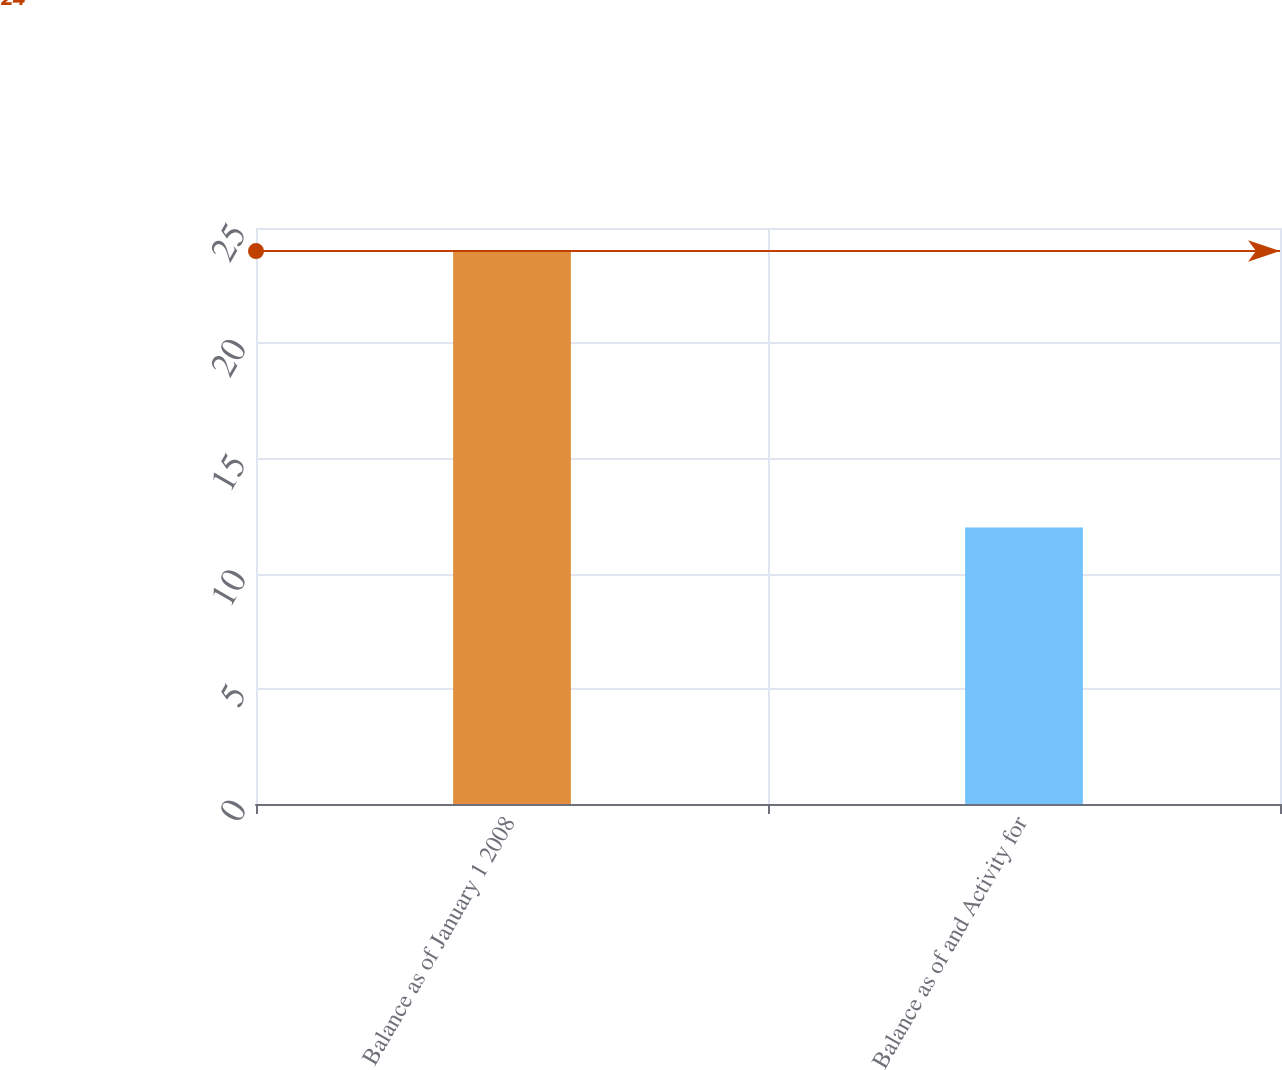<chart> <loc_0><loc_0><loc_500><loc_500><bar_chart><fcel>Balance as of January 1 2008<fcel>Balance as of and Activity for<nl><fcel>24<fcel>12<nl></chart> 